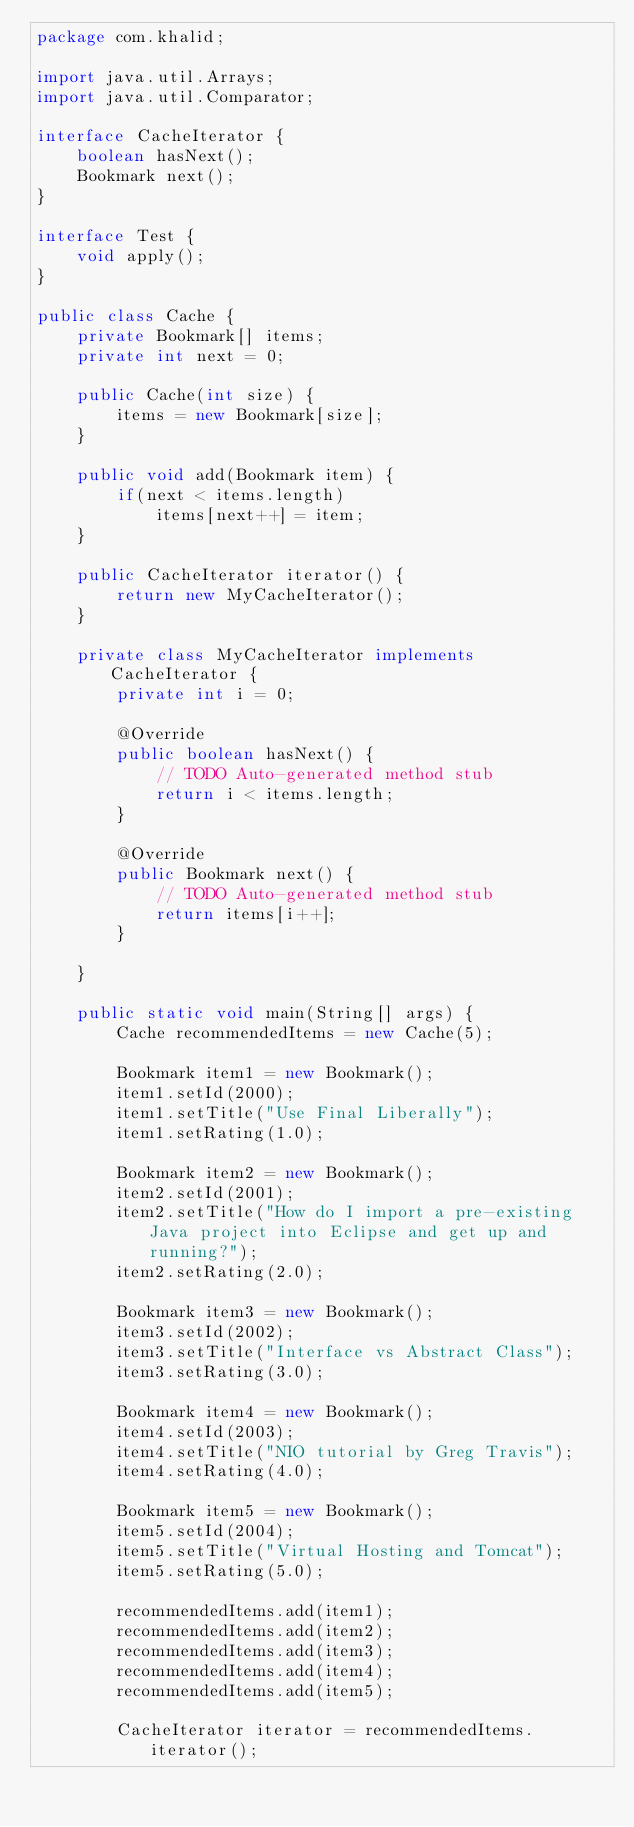Convert code to text. <code><loc_0><loc_0><loc_500><loc_500><_Java_>package com.khalid;

import java.util.Arrays;
import java.util.Comparator;

interface CacheIterator {
    boolean hasNext();
    Bookmark next();
}

interface Test {
	void apply();
}

public class Cache {		
	private Bookmark[] items;	
	private int next = 0;
	
	public Cache(int size) { 
    	items = new Bookmark[size]; 
    }
    
    public void add(Bookmark item) {
	    if(next < items.length)
            items[next++] = item;
    }
    
    public CacheIterator iterator() {
    	return new MyCacheIterator();    	
    }
    
    private class MyCacheIterator implements CacheIterator {
    	private int i = 0;
    	
		@Override
		public boolean hasNext() {
			// TODO Auto-generated method stub
			return i < items.length;
		}

		@Override
		public Bookmark next() {
			// TODO Auto-generated method stub
			return items[i++];
		}
    	
    }
    
    public static void main(String[] args) {
		Cache recommendedItems = new Cache(5);
		
		Bookmark item1 = new Bookmark();
		item1.setId(2000);
		item1.setTitle("Use Final Liberally");
		item1.setRating(1.0);
		
		Bookmark item2 = new Bookmark();
		item2.setId(2001);
		item2.setTitle("How do I import a pre-existing Java project into Eclipse and get up and running?");
		item2.setRating(2.0);
		
		Bookmark item3 = new Bookmark();
		item3.setId(2002);
		item3.setTitle("Interface vs Abstract Class");
		item3.setRating(3.0);
		
		Bookmark item4 = new Bookmark();
		item4.setId(2003);
		item4.setTitle("NIO tutorial by Greg Travis");
		item4.setRating(4.0);
		
		Bookmark item5 = new Bookmark();
		item5.setId(2004);
		item5.setTitle("Virtual Hosting and Tomcat");
		item5.setRating(5.0);
		
		recommendedItems.add(item1);
		recommendedItems.add(item2);
		recommendedItems.add(item3);
		recommendedItems.add(item4);
		recommendedItems.add(item5);
		
		CacheIterator iterator = recommendedItems.iterator();</code> 